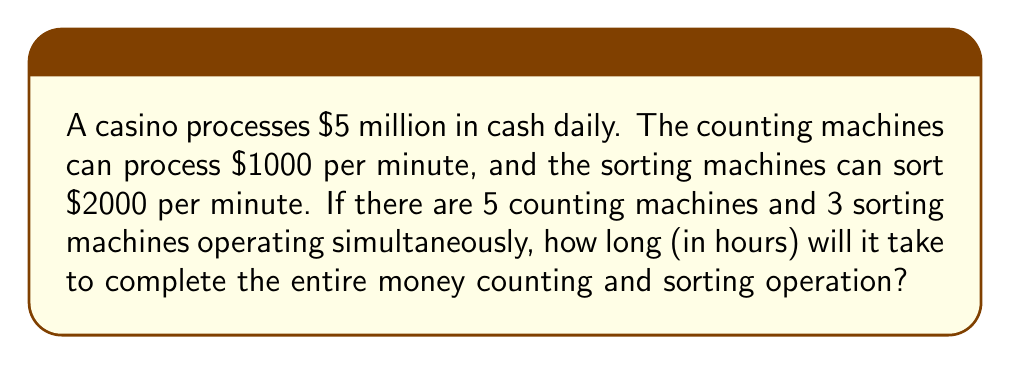What is the answer to this math problem? Let's break this down step-by-step:

1. Calculate the total processing capacity of counting machines:
   $5 \text{ machines} \times \$1000/\text{minute} = \$5000/\text{minute}$

2. Calculate the time needed for counting:
   $$\text{Counting time} = \frac{\$5,000,000}{\$5000/\text{minute}} = 1000 \text{ minutes}$$

3. Calculate the total processing capacity of sorting machines:
   $3 \text{ machines} \times \$2000/\text{minute} = \$6000/\text{minute}$

4. Calculate the time needed for sorting:
   $$\text{Sorting time} = \frac{\$5,000,000}{\$6000/\text{minute}} = 833.33 \text{ minutes}$$

5. The total operation time is the maximum of counting and sorting times:
   $\text{Total time} = \max(1000, 833.33) = 1000 \text{ minutes}$

6. Convert minutes to hours:
   $$\text{Total time in hours} = \frac{1000 \text{ minutes}}{60 \text{ minutes/hour}} = 16.67 \text{ hours}$$
Answer: 16.67 hours 